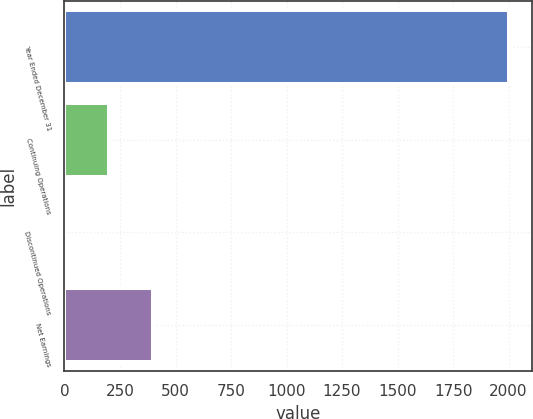<chart> <loc_0><loc_0><loc_500><loc_500><bar_chart><fcel>Year Ended December 31<fcel>Continuing Operations<fcel>Discontinued Operations<fcel>Net Earnings<nl><fcel>2004<fcel>200.45<fcel>0.05<fcel>400.85<nl></chart> 